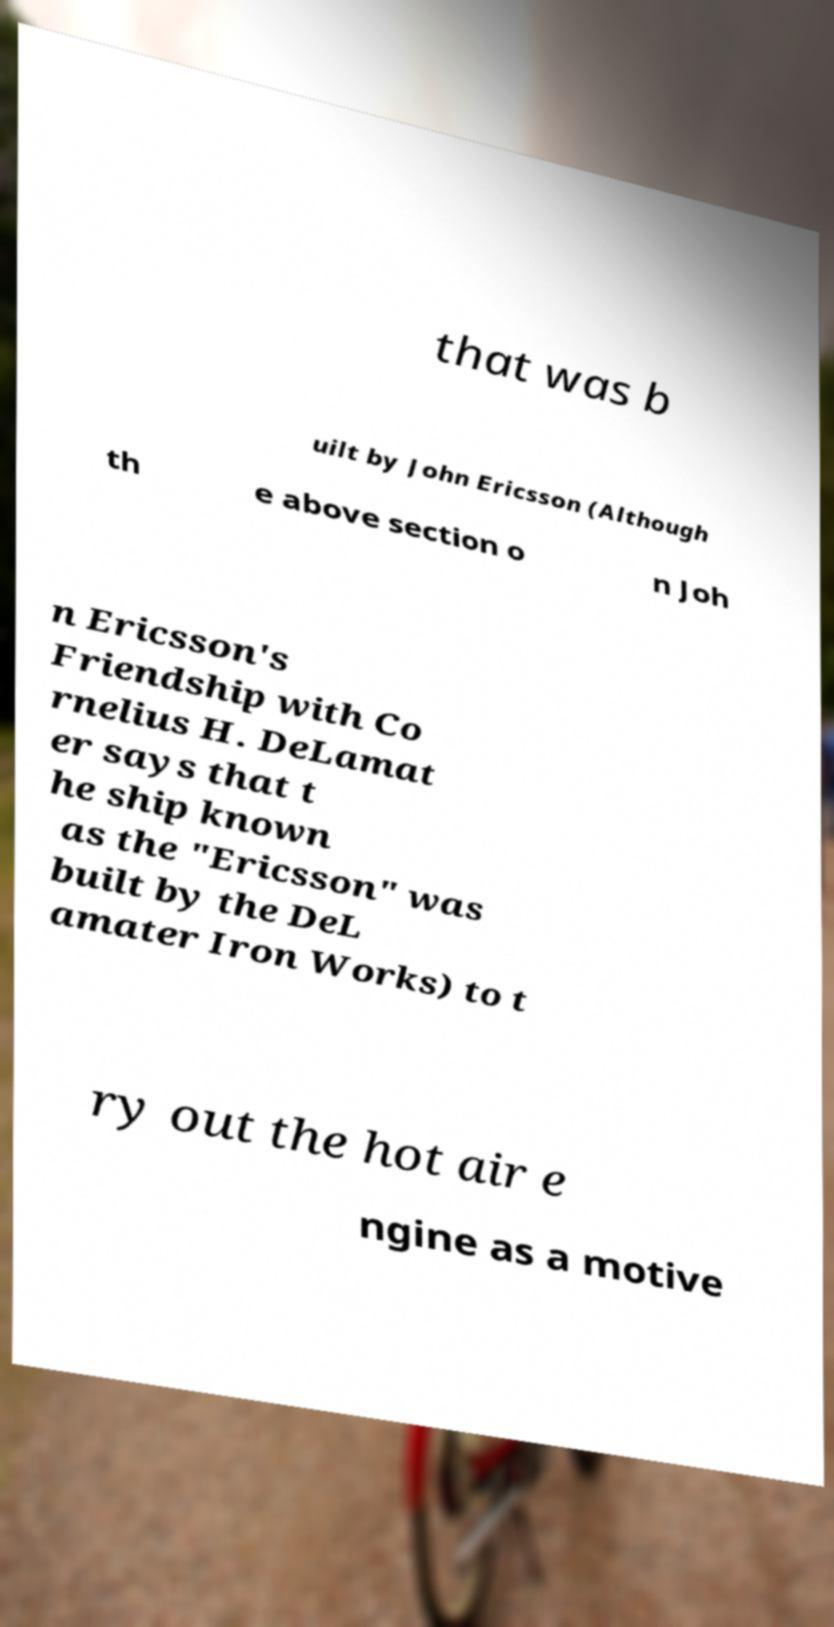Could you assist in decoding the text presented in this image and type it out clearly? that was b uilt by John Ericsson (Although th e above section o n Joh n Ericsson's Friendship with Co rnelius H. DeLamat er says that t he ship known as the "Ericsson" was built by the DeL amater Iron Works) to t ry out the hot air e ngine as a motive 